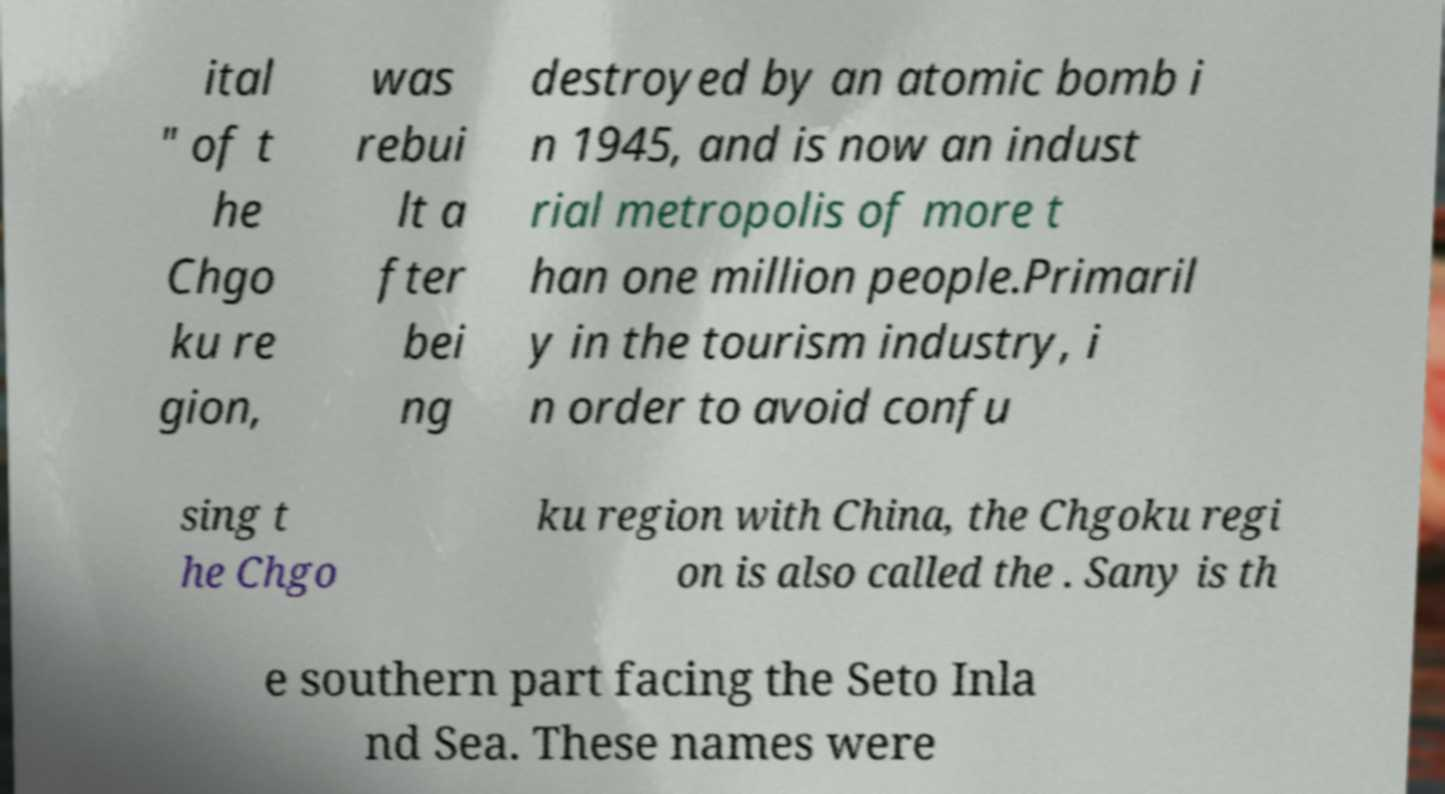Can you read and provide the text displayed in the image?This photo seems to have some interesting text. Can you extract and type it out for me? ital " of t he Chgo ku re gion, was rebui lt a fter bei ng destroyed by an atomic bomb i n 1945, and is now an indust rial metropolis of more t han one million people.Primaril y in the tourism industry, i n order to avoid confu sing t he Chgo ku region with China, the Chgoku regi on is also called the . Sany is th e southern part facing the Seto Inla nd Sea. These names were 